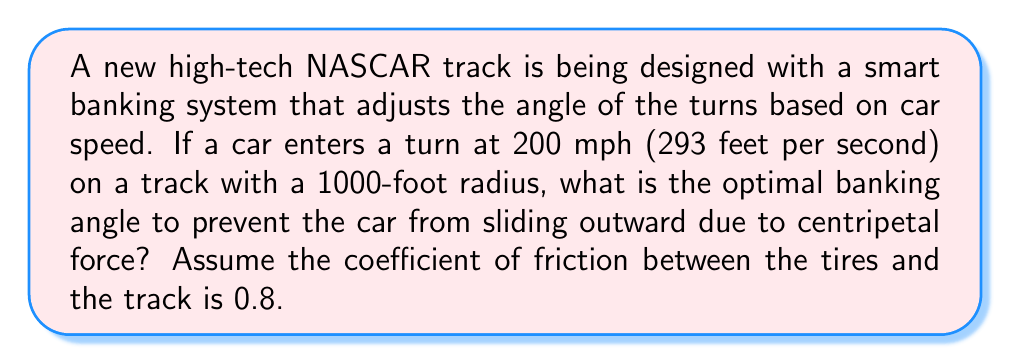Could you help me with this problem? To solve this problem, we'll use trigonometry and physics principles. Let's break it down step-by-step:

1. First, we need to understand the forces at play:
   - Centripetal force (F_c): the force needed to keep the car moving in a circular path
   - Friction force (F_f): the force between the tires and the track
   - Normal force (N): the force perpendicular to the track surface
   - Gravity (mg): the downward force due to the car's weight

2. The centripetal force is given by the formula:
   $$F_c = \frac{mv^2}{r}$$
   where m is the mass of the car, v is the velocity, and r is the radius of the turn.

3. We don't know the mass of the car, but we can use m to represent it in our equations.

4. Calculate the centripetal force:
   $$F_c = \frac{m(293)^2}{1000} = 85.849m$$

5. Now, let's consider the forces acting on the banked turn. We'll use θ to represent the banking angle:
   - The component of gravity parallel to the track: $mg \sin θ$
   - The component of gravity perpendicular to the track: $mg \cos θ$

6. For the car to not slide, the sum of the friction force and the parallel component of gravity must equal the centripetal force:
   $$F_f + mg \sin θ = F_c$$

7. The friction force is given by $F_f = μN$, where μ is the coefficient of friction (0.8) and N is the normal force.

8. The normal force is equal to the perpendicular component of gravity:
   $$N = mg \cos θ$$

9. Substituting these into our equation from step 6:
   $$0.8mg \cos θ + mg \sin θ = 85.849m$$

10. Divide both sides by mg:
    $$0.8 \cos θ + \sin θ = 85.849/g$$

11. Use the acceleration due to gravity, g = 32.2 ft/s²:
    $$0.8 \cos θ + \sin θ = 2.666$$

12. This equation can be solved using the trigonometric identity:
    $$a \cos θ + b \sin θ = \sqrt{a^2 + b^2} \sin(θ + \arctan(a/b))$$

13. In our case, a = 0.8 and b = 1. Solving:
    $$\sqrt{0.8^2 + 1^2} \sin(θ + \arctan(0.8)) = 2.666$$
    $$1.28 \sin(θ + 0.6747) = 2.666$$

14. Taking the arcsine of both sides:
    $$θ + 0.6747 = \arcsin(2.666/1.28) = 1.5634$$

15. Solving for θ:
    $$θ = 1.5634 - 0.6747 = 0.8887 \text{ radians}$$

16. Convert to degrees:
    $$θ = 0.8887 * (180/π) = 50.9°$$

Therefore, the optimal banking angle is approximately 50.9°.
Answer: 50.9° 